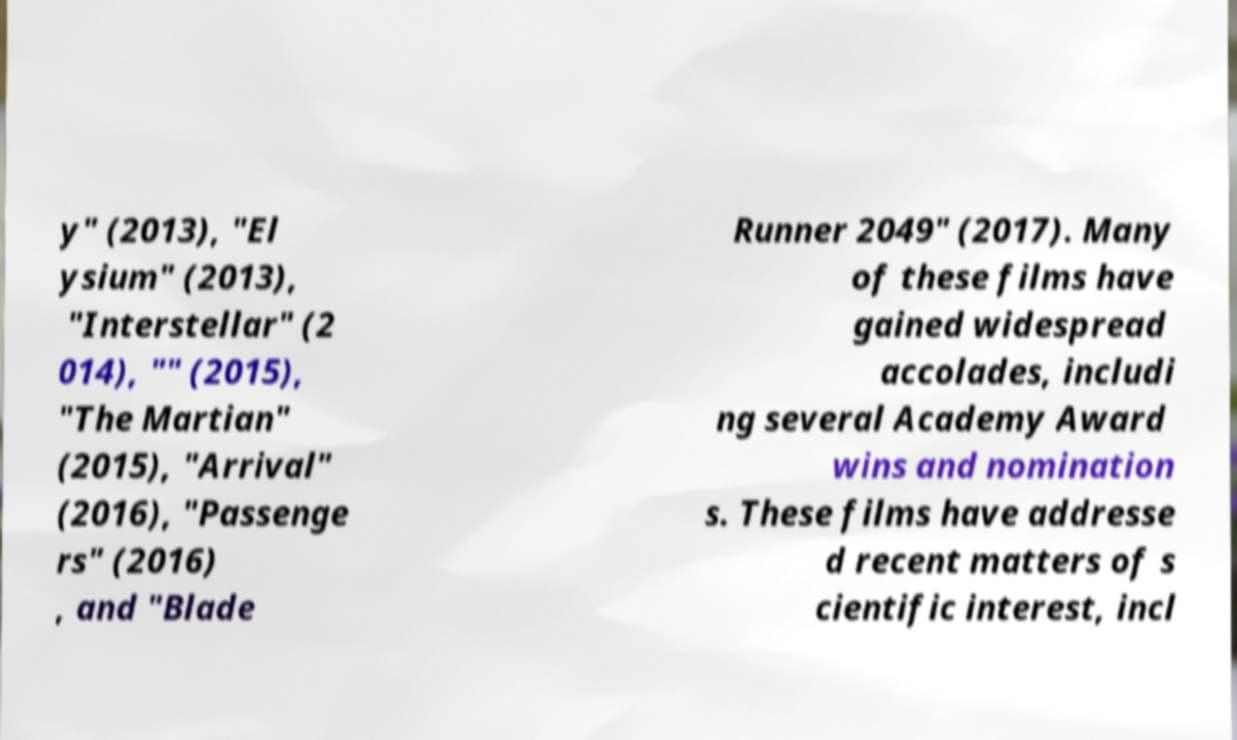Can you accurately transcribe the text from the provided image for me? y" (2013), "El ysium" (2013), "Interstellar" (2 014), "" (2015), "The Martian" (2015), "Arrival" (2016), "Passenge rs" (2016) , and "Blade Runner 2049" (2017). Many of these films have gained widespread accolades, includi ng several Academy Award wins and nomination s. These films have addresse d recent matters of s cientific interest, incl 